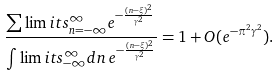<formula> <loc_0><loc_0><loc_500><loc_500>\frac { \sum \lim i t s _ { n = - \infty } ^ { \infty } e ^ { - \frac { ( n - \xi ) ^ { 2 } } { \gamma ^ { 2 } } } } { \int \lim i t s _ { - \infty } ^ { \infty } d n \, e ^ { - \frac { ( n - \xi ) ^ { 2 } } { \gamma ^ { 2 } } } } = 1 + O ( e ^ { - \pi ^ { 2 } \gamma ^ { 2 } } ) .</formula> 